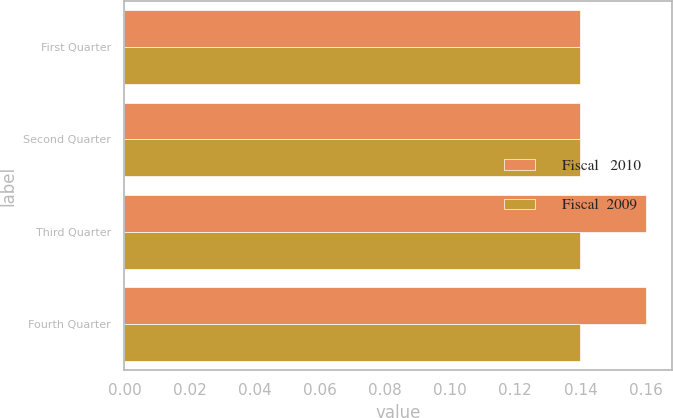Convert chart. <chart><loc_0><loc_0><loc_500><loc_500><stacked_bar_chart><ecel><fcel>First Quarter<fcel>Second Quarter<fcel>Third Quarter<fcel>Fourth Quarter<nl><fcel>Fiscal   2010<fcel>0.14<fcel>0.14<fcel>0.16<fcel>0.16<nl><fcel>Fiscal  2009<fcel>0.14<fcel>0.14<fcel>0.14<fcel>0.14<nl></chart> 